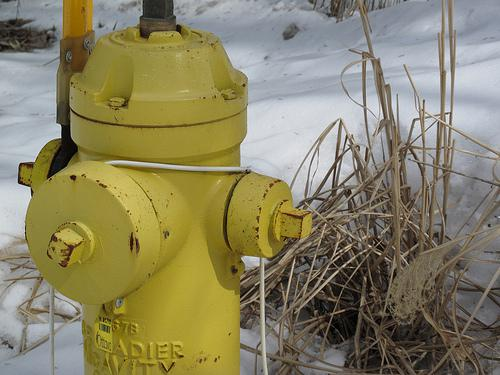Question: where is the hydrant?
Choices:
A. On the sidewalk.
B. Around the corner.
C. Across the street.
D. In the snow.
Answer with the letter. Answer: D Question: what color is the snow?
Choices:
A. Yellow.
B. Red.
C. Black.
D. White.
Answer with the letter. Answer: D Question: how many people are in the picture?
Choices:
A. 4.
B. 5.
C. None.
D. 6.
Answer with the letter. Answer: C Question: what season does this take place in?
Choices:
A. Winter.
B. Spring.
C. Summer.
D. Fall.
Answer with the letter. Answer: A Question: how many animals are pictured?
Choices:
A. 7.
B. None.
C. 89.
D. 9.
Answer with the letter. Answer: B 